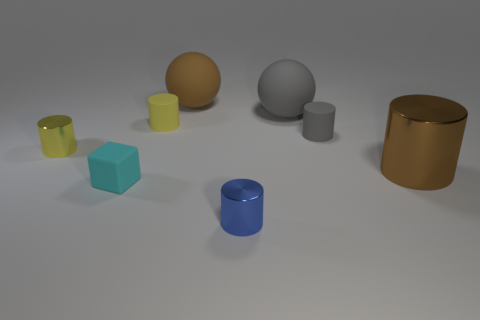Subtract all green cubes. How many yellow cylinders are left? 2 Add 2 brown metal objects. How many objects exist? 10 Subtract all rubber cylinders. How many cylinders are left? 3 Subtract all cylinders. How many objects are left? 3 Subtract all brown cylinders. How many cylinders are left? 4 Subtract all red cylinders. Subtract all gray spheres. How many cylinders are left? 5 Add 4 small gray matte cubes. How many small gray matte cubes exist? 4 Subtract 0 red balls. How many objects are left? 8 Subtract all brown metal cylinders. Subtract all small yellow rubber cylinders. How many objects are left? 6 Add 3 small gray things. How many small gray things are left? 4 